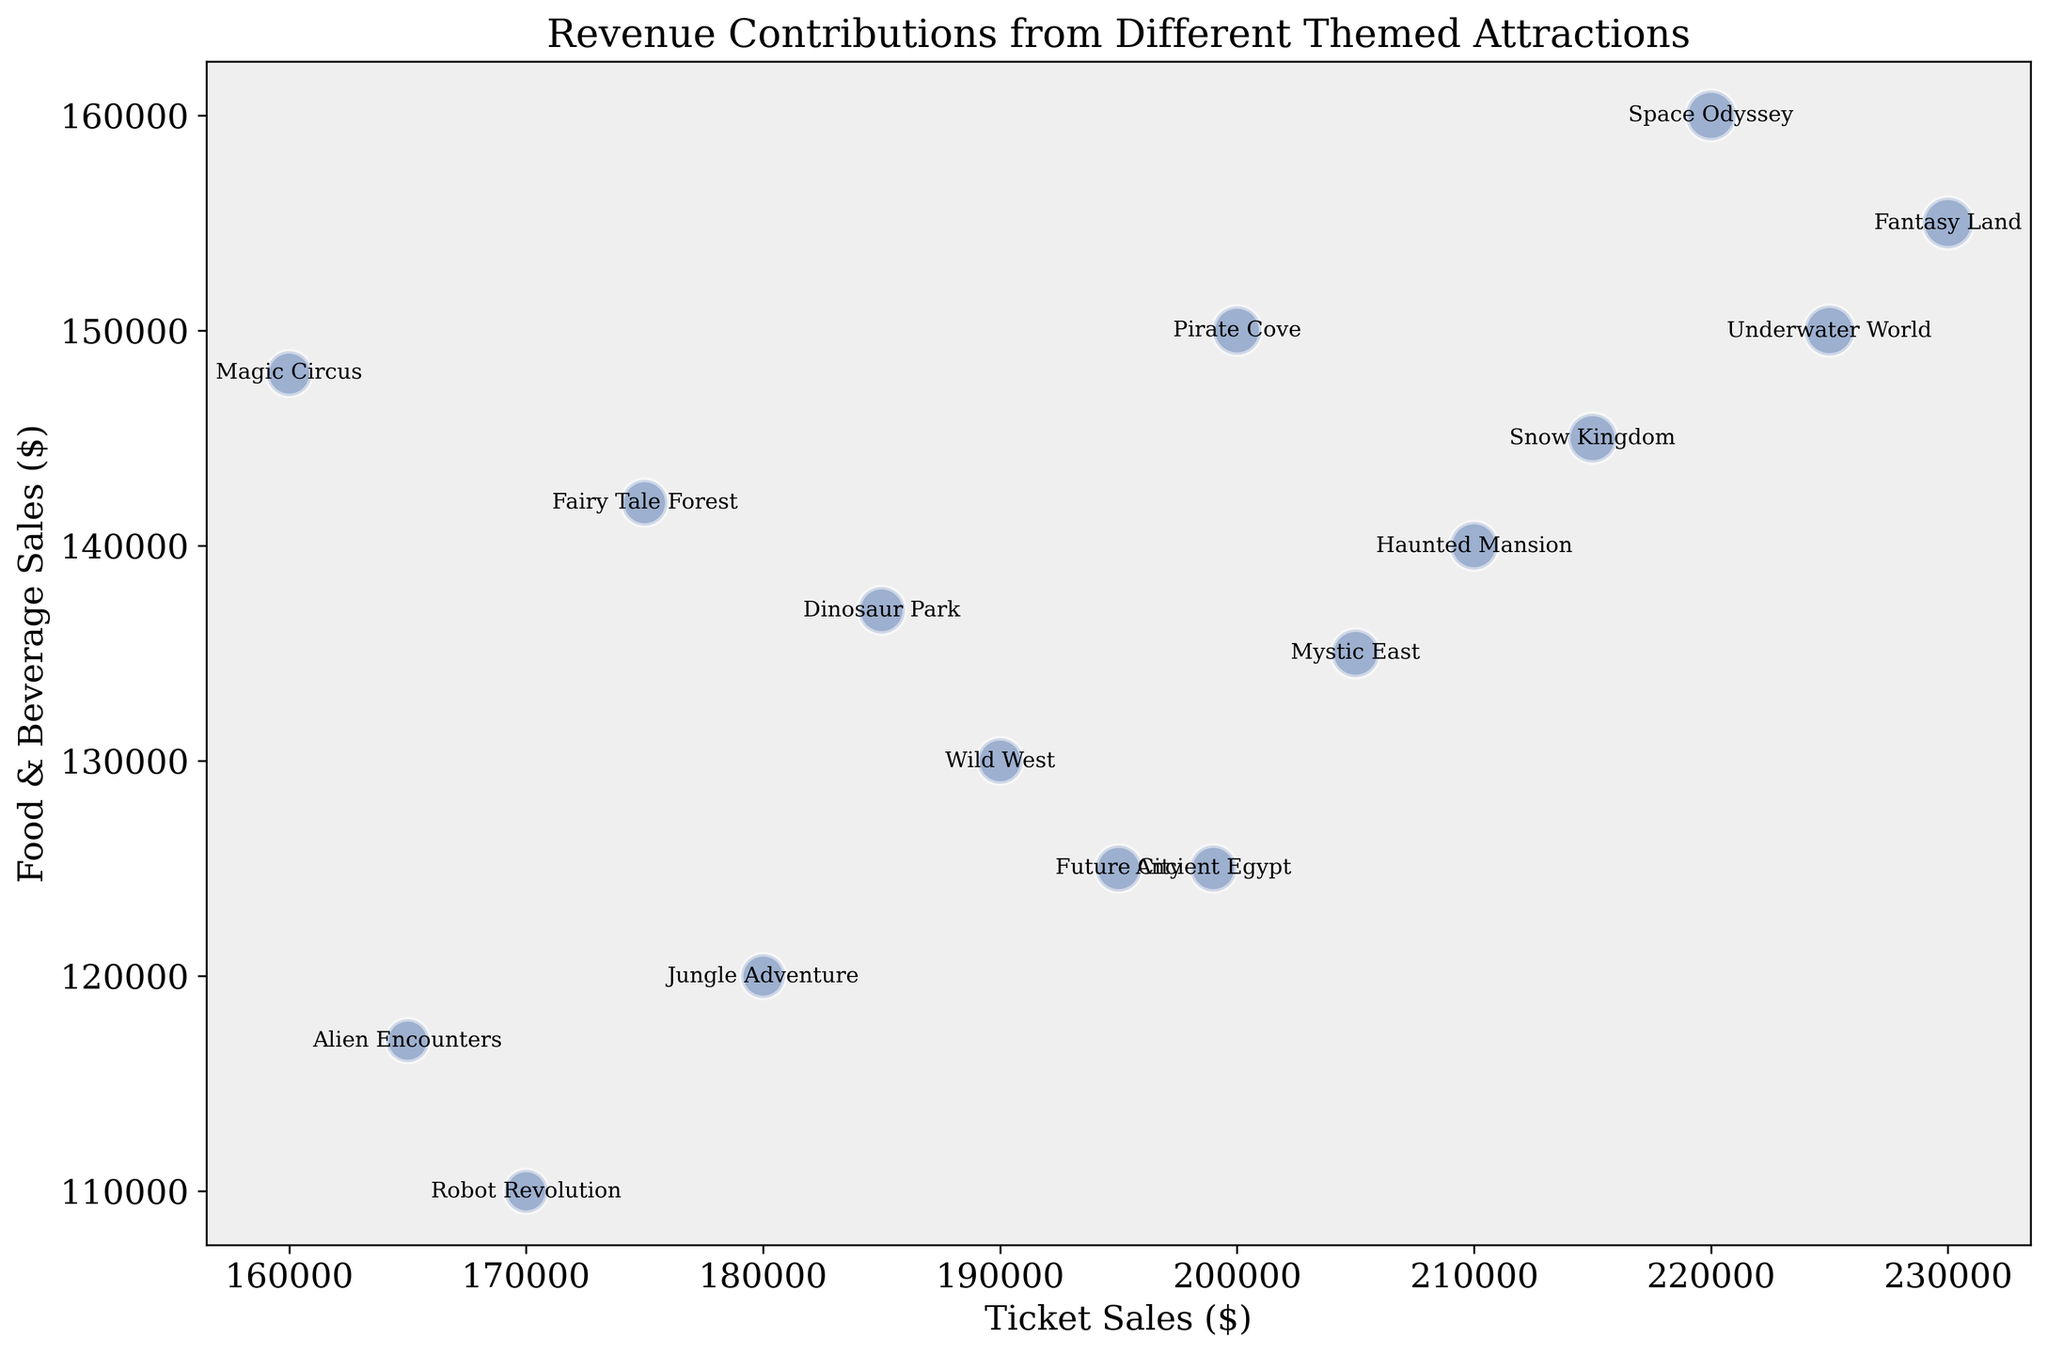Which attraction has the highest ticket sales? Look at the x-axis (Ticket Sales) and find the bubble furthest to the right. Fantasy Land is the attraction with the highest ticket sales.
Answer: Fantasy Land Which attraction has the lowest food and beverage sales? Look at the y-axis (Food & Beverage Sales) and find the bubble closest to the bottom. Robot Revolution has the lowest food and beverage sales.
Answer: Robot Revolution Between "Pirate Cove" and "Space Odyssey", which attraction has higher merchandise sales? Compare the merchandise sales values for "Pirate Cove" ($50,000) and "Space Odyssey" ($45,000), which are annotated on the bubbles.
Answer: Pirate Cove Which attraction has the largest bubble on the chart? The bubble size represents the combined revenue from ticket sales, merchandise sales, and food and beverage sales. The largest bubble corresponds to Fantasy Land, as it has the highest combined revenue.
Answer: Fantasy Land How do the food and beverage sales of "Haunted Mansion" and "Dinosaur Park" compare? Look at the y-axis (Food & Beverage Sales) for both "Haunted Mansion" and "Dinosaur Park". "Haunted Mansion" has $140,000 and "Dinosaur Park" has $137,000, making Haunted Mansion slightly higher.
Answer: Haunted Mansion What is the combined revenue (merchandise + ticket + food and beverage) for "Underwater World"? Sum up the values: Merchandise Sales ($52,000) + Ticket Sales ($225,000) + Food & Beverage ($150,000). The combined revenue is $52,000 + $225,000 + $150,000 = $427,000.
Answer: $427,000 Which attractions have ticket sales between $200,000 and $210,000? Find the bubbles whose x-coordinate (Ticket Sales) falls between $200,000 and $210,000. These attractions are "Pirate Cove", "Haunted Mansion", and "Mystic East".
Answer: Pirate Cove, Haunted Mansion, Mystic East If you combine the ticket sales for "Robot Revolution" and "Alien Encounters", what would be the total? Add the ticket sales values: Robot Revolution ($170,000) + Alien Encounters ($165,000). The total is $170,000 + $165,000 = $335,000.
Answer: $335,000 Which attraction has a higher food and beverage sales, "Mystic East" or "Future City"? Compare the y-axis positions (Food & Beverage Sales) for "Mystic East" ($135,000) and "Future City" ($125,000). Mystic East has higher food and beverage sales.
Answer: Mystic East What is the average ticket sales value of the attractions? Sum up all the ticket sales values and divide by the number of attractions. \$200,000 + \$180,000 + \$220,000 + \$210,000 + \$230,000 + \$190,000 + \$205,000 + \$225,000 + \$215,000 + \$195,000 + \$185,000 + \$175,000 + \$160,000 + \$170,000 + \$165,000 + \$199,000 = \$3,324,000. Divide by 16, the total number of attractions. The average ticket sales value is \$3,324,000 / 16 = \$207,750.
Answer: $207,750 